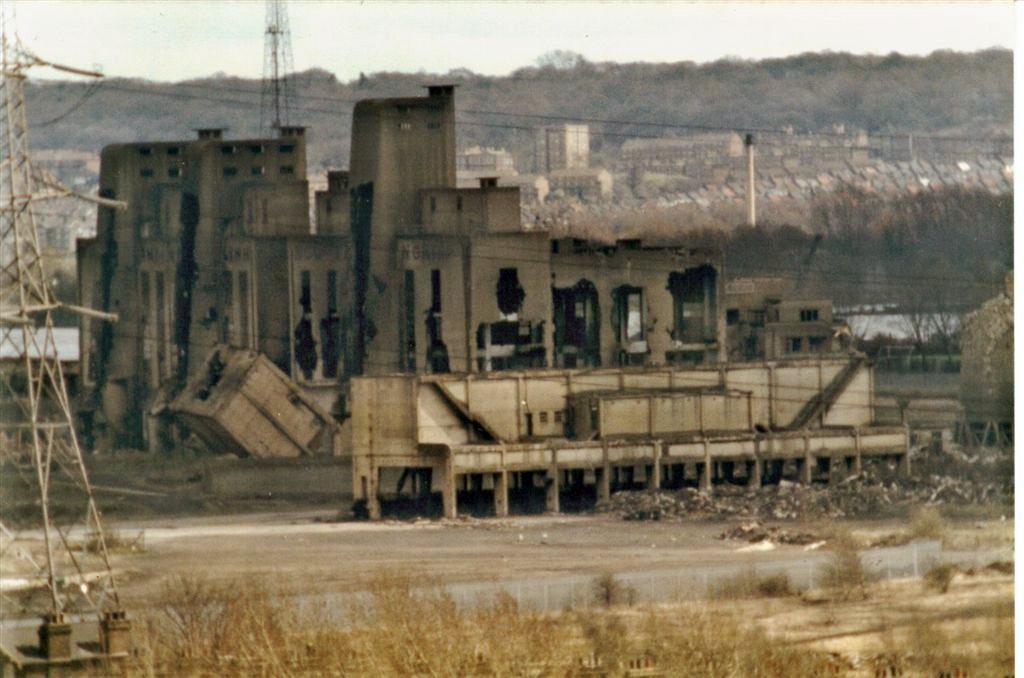How would you summarize this image in a sentence or two? In the image we can see there is an old building and there is an electric pole tower. The ground is covered with dry plants. 